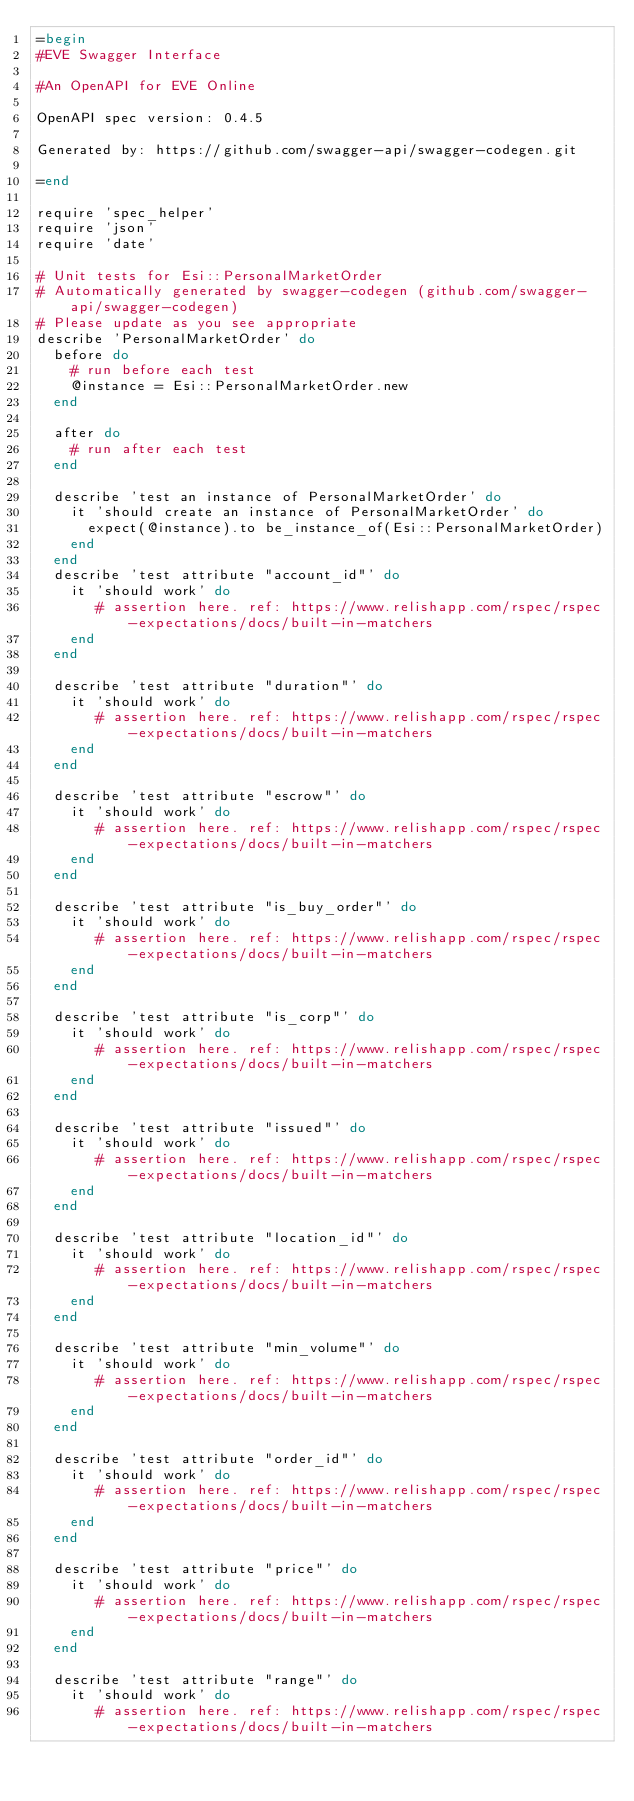<code> <loc_0><loc_0><loc_500><loc_500><_Ruby_>=begin
#EVE Swagger Interface

#An OpenAPI for EVE Online

OpenAPI spec version: 0.4.5

Generated by: https://github.com/swagger-api/swagger-codegen.git

=end

require 'spec_helper'
require 'json'
require 'date'

# Unit tests for Esi::PersonalMarketOrder
# Automatically generated by swagger-codegen (github.com/swagger-api/swagger-codegen)
# Please update as you see appropriate
describe 'PersonalMarketOrder' do
  before do
    # run before each test
    @instance = Esi::PersonalMarketOrder.new
  end

  after do
    # run after each test
  end

  describe 'test an instance of PersonalMarketOrder' do
    it 'should create an instance of PersonalMarketOrder' do
      expect(@instance).to be_instance_of(Esi::PersonalMarketOrder)
    end
  end
  describe 'test attribute "account_id"' do
    it 'should work' do
       # assertion here. ref: https://www.relishapp.com/rspec/rspec-expectations/docs/built-in-matchers
    end
  end

  describe 'test attribute "duration"' do
    it 'should work' do
       # assertion here. ref: https://www.relishapp.com/rspec/rspec-expectations/docs/built-in-matchers
    end
  end

  describe 'test attribute "escrow"' do
    it 'should work' do
       # assertion here. ref: https://www.relishapp.com/rspec/rspec-expectations/docs/built-in-matchers
    end
  end

  describe 'test attribute "is_buy_order"' do
    it 'should work' do
       # assertion here. ref: https://www.relishapp.com/rspec/rspec-expectations/docs/built-in-matchers
    end
  end

  describe 'test attribute "is_corp"' do
    it 'should work' do
       # assertion here. ref: https://www.relishapp.com/rspec/rspec-expectations/docs/built-in-matchers
    end
  end

  describe 'test attribute "issued"' do
    it 'should work' do
       # assertion here. ref: https://www.relishapp.com/rspec/rspec-expectations/docs/built-in-matchers
    end
  end

  describe 'test attribute "location_id"' do
    it 'should work' do
       # assertion here. ref: https://www.relishapp.com/rspec/rspec-expectations/docs/built-in-matchers
    end
  end

  describe 'test attribute "min_volume"' do
    it 'should work' do
       # assertion here. ref: https://www.relishapp.com/rspec/rspec-expectations/docs/built-in-matchers
    end
  end

  describe 'test attribute "order_id"' do
    it 'should work' do
       # assertion here. ref: https://www.relishapp.com/rspec/rspec-expectations/docs/built-in-matchers
    end
  end

  describe 'test attribute "price"' do
    it 'should work' do
       # assertion here. ref: https://www.relishapp.com/rspec/rspec-expectations/docs/built-in-matchers
    end
  end

  describe 'test attribute "range"' do
    it 'should work' do
       # assertion here. ref: https://www.relishapp.com/rspec/rspec-expectations/docs/built-in-matchers</code> 